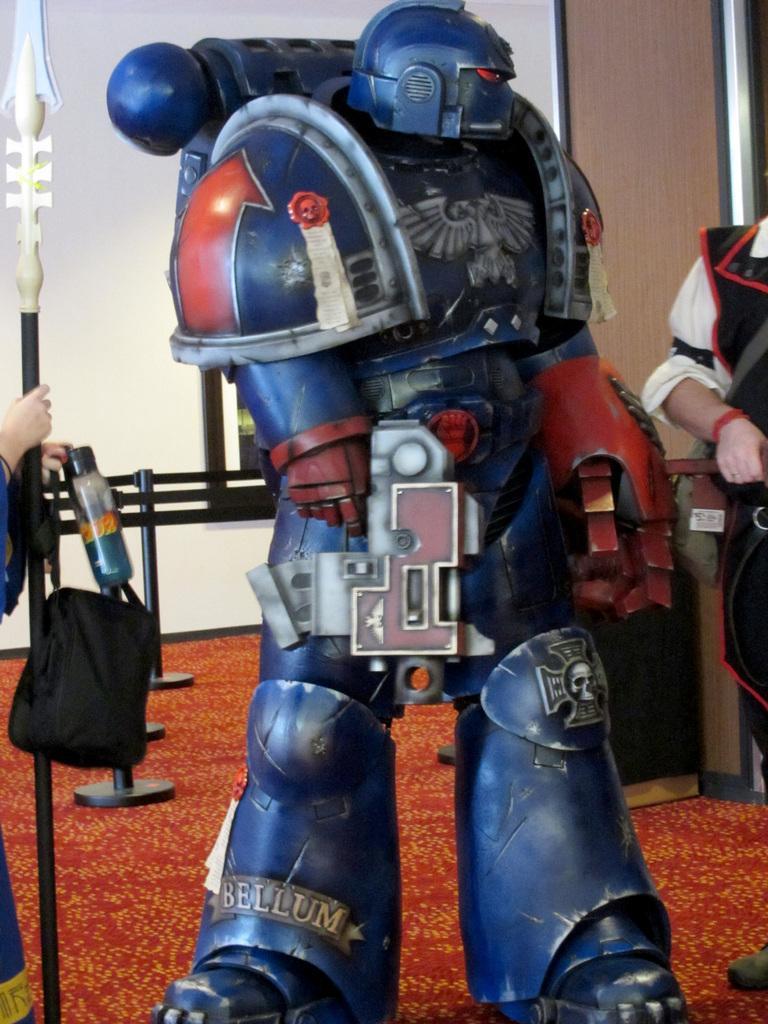Could you give a brief overview of what you see in this image? In this image I can see a transformer shaped toy in blue color. On the right side a man is standing, at the bottom it is the floor mat. 